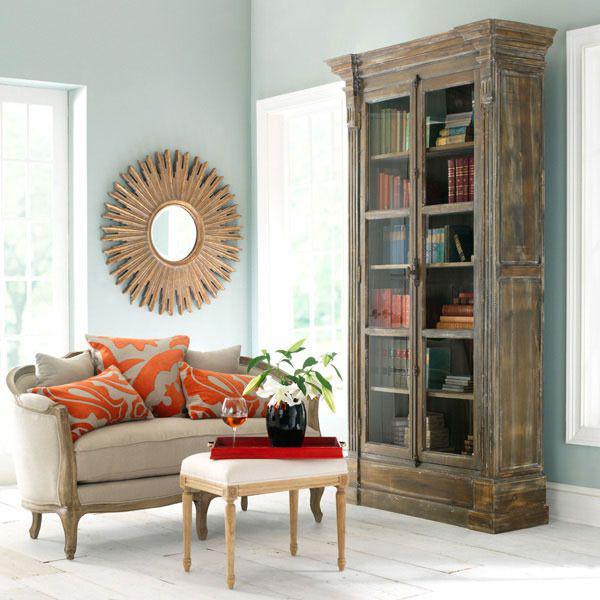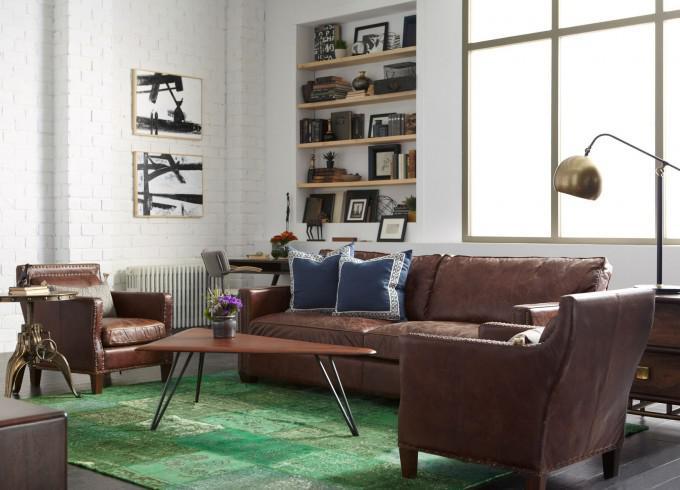The first image is the image on the left, the second image is the image on the right. Given the left and right images, does the statement "A gooseneck lamp is in front of a large paned window in a room with a sofa and coffee table." hold true? Answer yes or no. Yes. The first image is the image on the left, the second image is the image on the right. Analyze the images presented: Is the assertion "there is a white built in bookshelf with a sofa , two chairs and a coffee table in front of it" valid? Answer yes or no. Yes. 